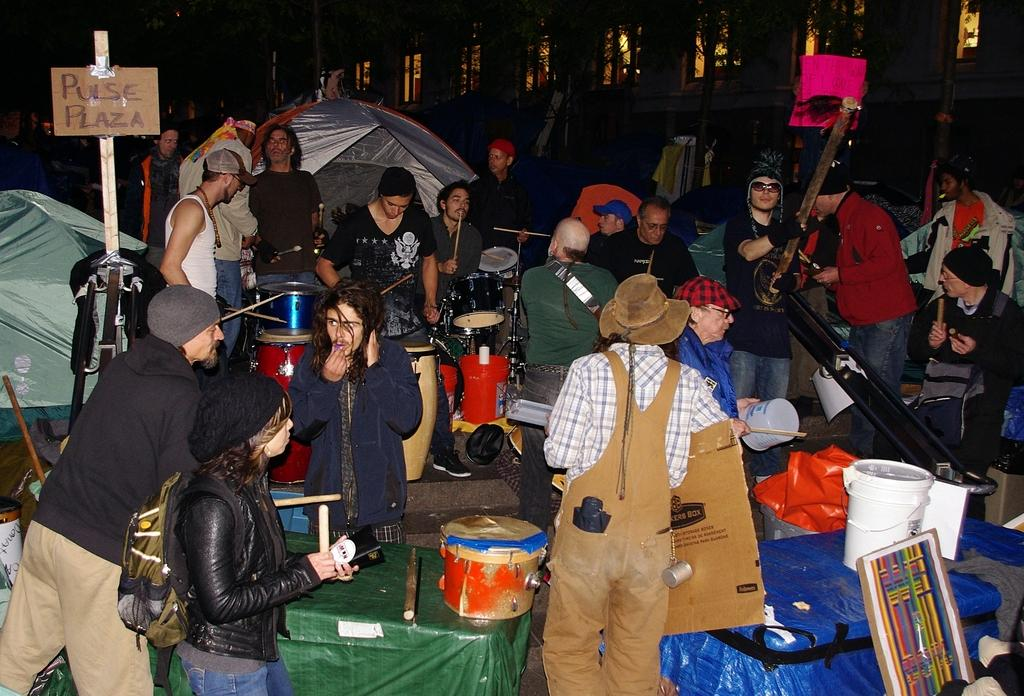How many people can be seen in the image? There are people in the image, but the exact number is not specified. What are the people doing in the image? The people are likely playing musical instruments, as they are present in the image. What are the boxes used for in the image? The purpose of the boxes is not specified, but they are visible in the image. What is the board on a pole used for in the image? The purpose of the board on a pole is not specified, but it is visible in the image. What other objects can be seen on the path in the image? Other objects are visible on the path, but their specifics are not provided. What type of building is visible in the image? The type of building visible in the image is not specified. What type of meal is being prepared in the image? There is no mention of a meal being prepared in the image. 